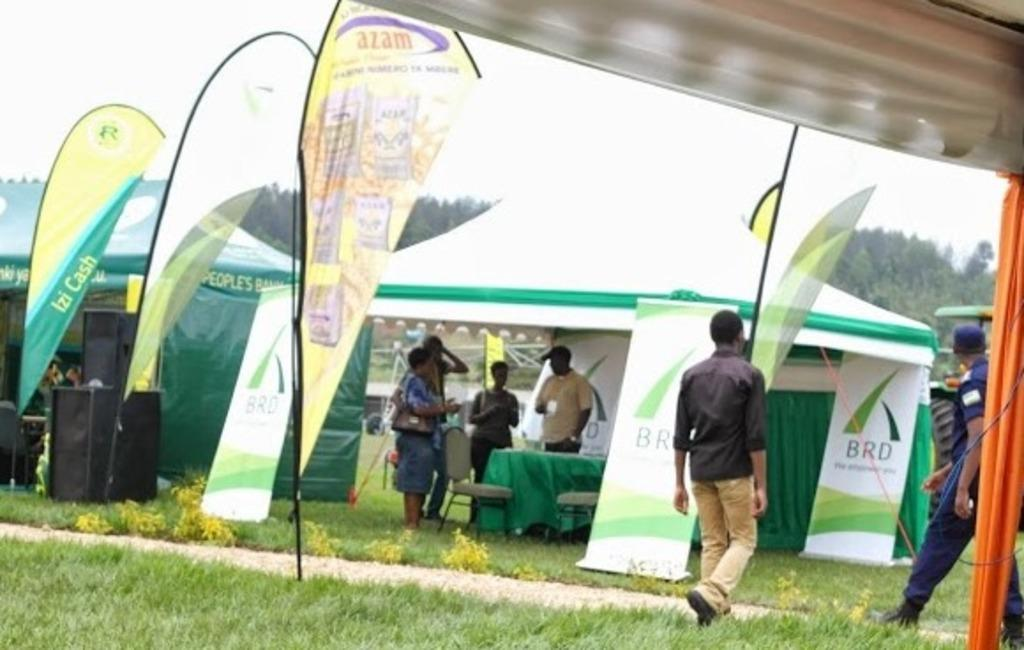What are the persons in the image doing under the parasols? The persons are standing under parasols in the image. What are some of the persons doing on the grass? Some persons are walking on the grass in the image. What can be seen on the advertisements in the image? The content of the advertisements cannot be determined from the image. What might be used for amplifying sound in the image? Speakers are present in the image for amplifying sound. What type of furniture is visible in the image? Tables and chairs are present in the image. What type of natural environment is visible in the image? Trees and the sky are visible in the image. What type of car is the person driving in the image? There is no car or person driving in the image. What is the title of the book the person is reading in the image? There is no book or person reading in the image. 